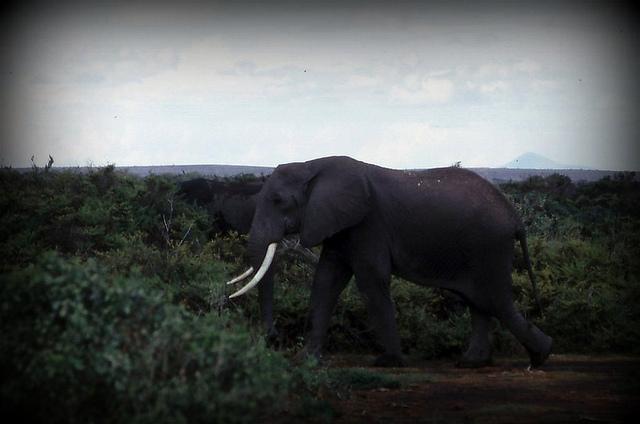Are the tusks long relative to the elephants?
Give a very brief answer. Yes. Is this an Indian or an African elephant?
Answer briefly. African. Are these animals in their natural setting?
Answer briefly. Yes. Is he in a zoo?
Keep it brief. No. Is the elephant at the zoo?
Quick response, please. No. Is that a sunset?
Keep it brief. No. What color is the elephant?
Short answer required. Gray. Is there a baby elephant shown?
Quick response, please. No. Where is the elephant?
Short answer required. Outside. Is this an African or Asian elephant?
Answer briefly. African. How big are the elephants ears?
Short answer required. Big. Was this photo edited with more light?
Quick response, please. No. What is the elephant doing?
Short answer required. Walking. What is on the animals back?
Be succinct. Dirt. Is there a rock in the picture?
Give a very brief answer. No. What color is this elephant?
Be succinct. Gray. How many birds are in this picture?
Quick response, please. 0. What time of day is it?
Give a very brief answer. Afternoon. Are there people in this photo?
Quick response, please. No. How tall are the tree's?
Answer briefly. Short. What is the elephant doing to the tree?
Quick response, please. Pushing. Is this animal in its natural habitat?
Concise answer only. Yes. Is this a zoo?
Short answer required. No. What is shooting out of the elephant's trunk?
Answer briefly. Nothing. Are there clouds in the sky?
Keep it brief. Yes. How many tusks are visible?
Be succinct. 2. Would he be able to fend for himself in the wild?
Concise answer only. Yes. 